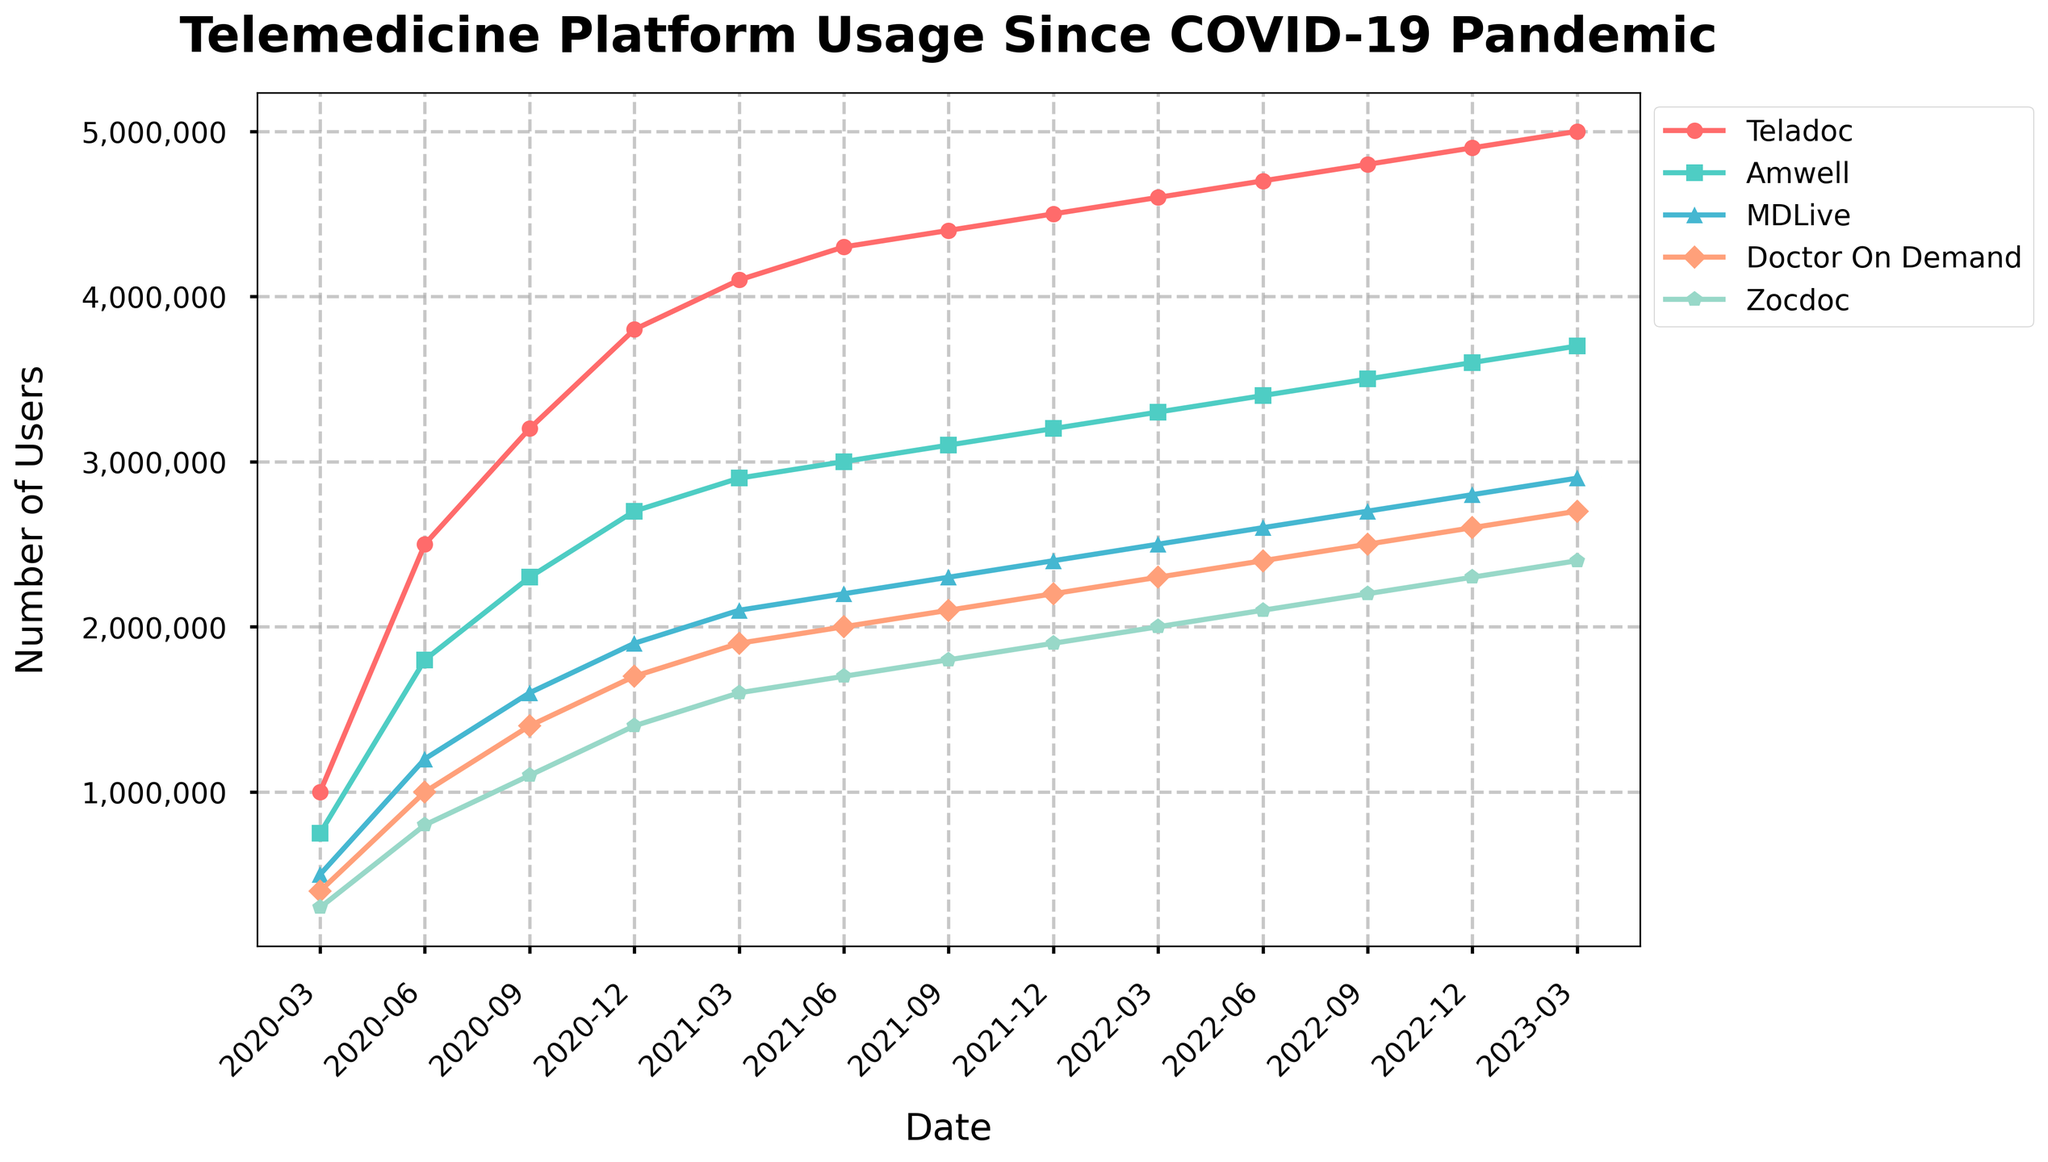Which telemedicine platform had the greatest increase in users from March 2020 to March 2023? To determine the greatest increase, subtract the user count in March 2020 from the user count in March 2023 for each platform. Teladoc increased from 1,000,000 to 5,000,000 (4,000,000 increase), Amwell from 750,000 to 3,700,000 (2,950,000 increase), MDLive from 500,000 to 2,900,000 (2,400,000 increase), Doctor On Demand from 400,000 to 2,700,000 (2,300,000 increase), Zocdoc from 300,000 to 2,400,000 (2,100,000 increase). Teladoc had the greatest increase.
Answer: Teladoc Which platform had the least number of users in December 2022? Check the user counts for each platform in December 2022: Teladoc (4,900,000), Amwell (3,600,000), MDLive (2,800,000), Doctor On Demand (2,600,000), Zocdoc (2,300,000). Zocdoc had the least number of users.
Answer: Zocdoc How did the usage of Amwell change between September 2021 and March 2022? Observe user counts for Amwell in September 2021 (3,100,000) and March 2022 (3,300,000). The change is calculated by subtracting September 2021 values from those of March 2022: 3,300,000 - 3,100,000 = 200,000. Usage increased by 200,000.
Answer: Increased by 200,000 In which period did MDLive see the highest growth rate? Calculate the growth rate between consecutive periods for MDLive and find the highest: From March 2020 to June 2020, MDLive grew from 500,000 to 1,200,000, which is a growth of 700,000. This is the highest single-period growth rate in comparison to other periods.
Answer: March 2020 to June 2020 Which two platforms had user counts closest to each other in December 2021? Comparing user counts in December 2021: Teladoc (4,500,000), Amwell (3,200,000), MDLive (2,400,000), Doctor On Demand (2,200,000), Zocdoc (1,900,000). MDLive and Doctor On Demand have the closest counts with only 200,000 difference (2,400,000 - 2,200,000).
Answer: MDLive and Doctor On Demand What was the average number of users for Zocdoc across all given periods? Sum up the user counts for Zocdoc for all periods and divide by the number of periods: (300,000 + 800,000 + 1,100,000 + 1,400,000 + 1,600,000 + 1,700,000 + 1,800,000 + 1,900,000 + 2,000,000 + 2,100,000 + 2,200,000 + 2,300,000 + 2,400,000) / 13 = 1,546,154 users on average.
Answer: 1,546,154 Which telemedicine platform experienced the most consistent growth over the period? Evaluating the user growth for each platform by comparing increments over the periods, Teladoc shows the most consistent growth pattern with an increase in each period without any drop or plateau.
Answer: Teladoc 